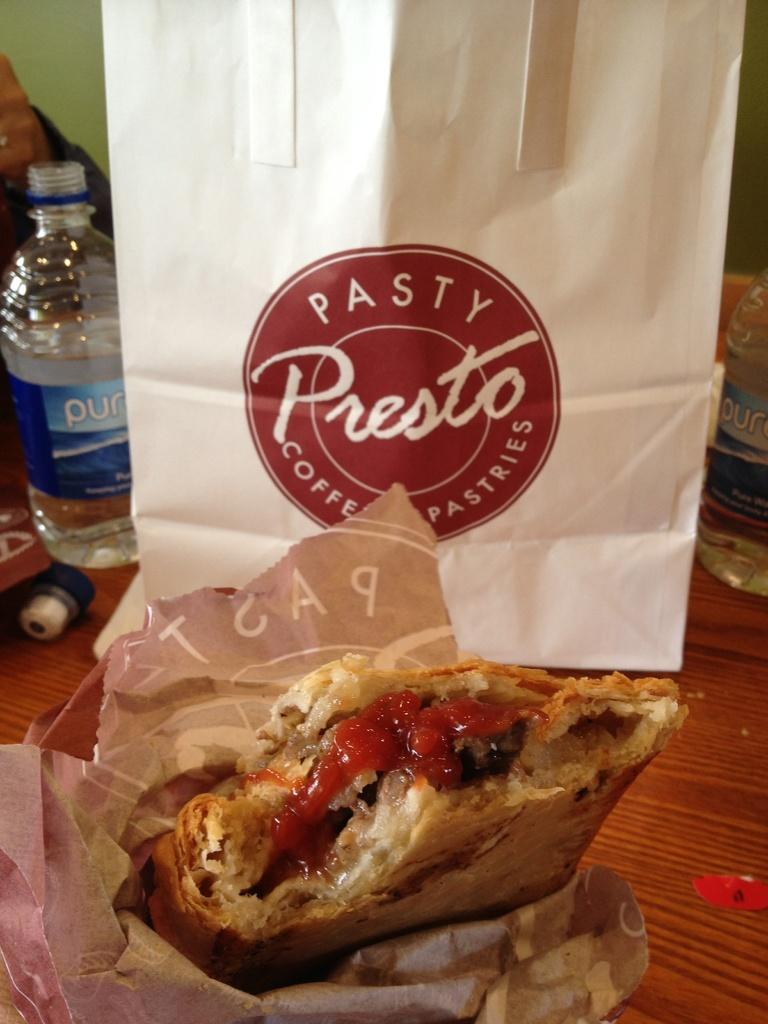What type of food can be seen in the image? There is food in the image, but the specific type is not mentioned. What is the name of the carry bag in the image? The carry bag in the image has the name "PASTA" on it. What is another item visible in the image? There is a water bottle in the image. What type of cushion is being used to celebrate the birthday in the image? There is no cushion or birthday celebration present in the image. 